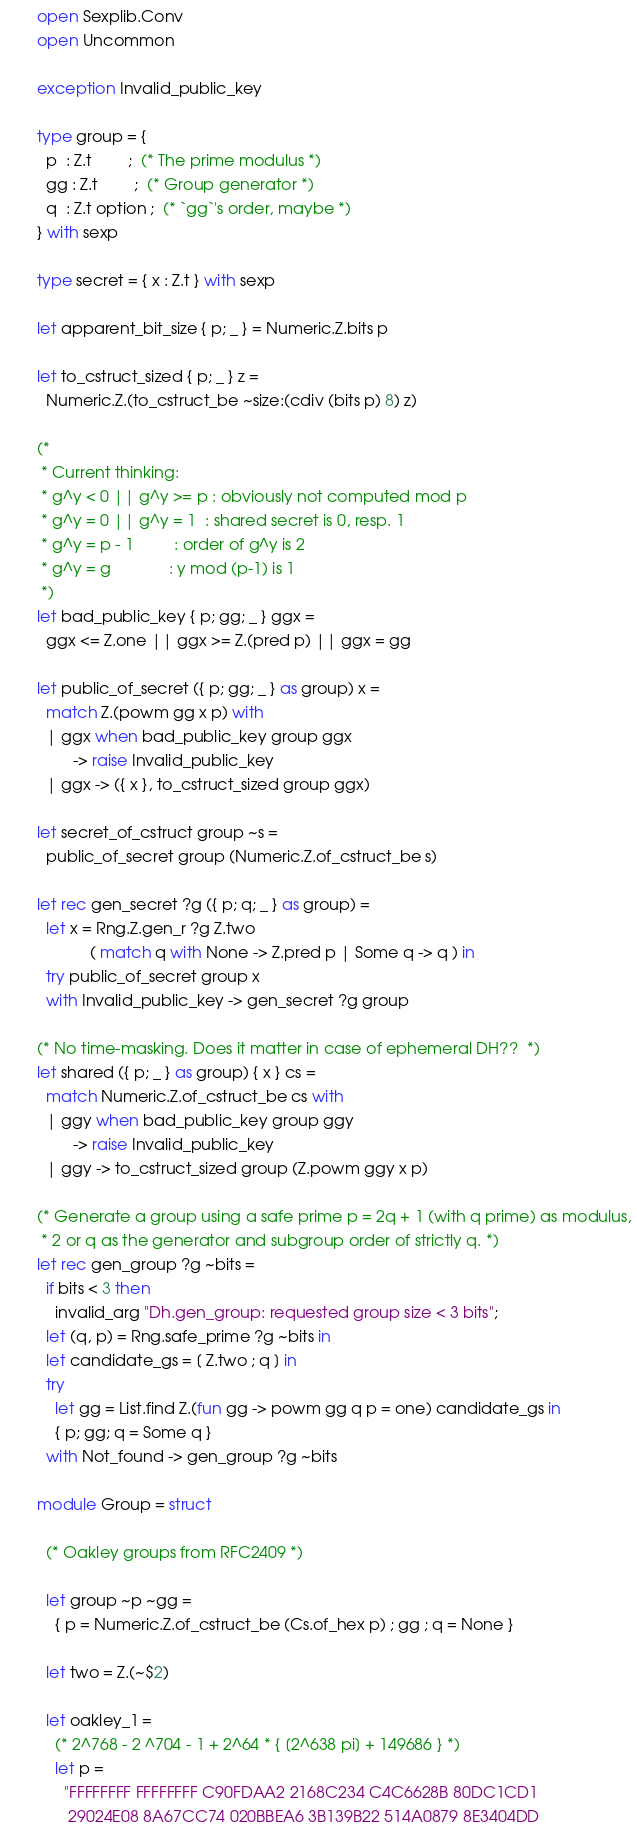<code> <loc_0><loc_0><loc_500><loc_500><_OCaml_>open Sexplib.Conv
open Uncommon

exception Invalid_public_key

type group = {
  p  : Z.t        ;  (* The prime modulus *)
  gg : Z.t        ;  (* Group generator *)
  q  : Z.t option ;  (* `gg`'s order, maybe *)
} with sexp

type secret = { x : Z.t } with sexp

let apparent_bit_size { p; _ } = Numeric.Z.bits p

let to_cstruct_sized { p; _ } z =
  Numeric.Z.(to_cstruct_be ~size:(cdiv (bits p) 8) z)

(*
 * Current thinking:
 * g^y < 0 || g^y >= p : obviously not computed mod p
 * g^y = 0 || g^y = 1  : shared secret is 0, resp. 1
 * g^y = p - 1         : order of g^y is 2
 * g^y = g             : y mod (p-1) is 1
 *)
let bad_public_key { p; gg; _ } ggx =
  ggx <= Z.one || ggx >= Z.(pred p) || ggx = gg

let public_of_secret ({ p; gg; _ } as group) x =
  match Z.(powm gg x p) with
  | ggx when bad_public_key group ggx
        -> raise Invalid_public_key
  | ggx -> ({ x }, to_cstruct_sized group ggx)

let secret_of_cstruct group ~s =
  public_of_secret group (Numeric.Z.of_cstruct_be s)

let rec gen_secret ?g ({ p; q; _ } as group) =
  let x = Rng.Z.gen_r ?g Z.two
            ( match q with None -> Z.pred p | Some q -> q ) in
  try public_of_secret group x
  with Invalid_public_key -> gen_secret ?g group

(* No time-masking. Does it matter in case of ephemeral DH??  *)
let shared ({ p; _ } as group) { x } cs =
  match Numeric.Z.of_cstruct_be cs with
  | ggy when bad_public_key group ggy
        -> raise Invalid_public_key
  | ggy -> to_cstruct_sized group (Z.powm ggy x p)

(* Generate a group using a safe prime p = 2q + 1 (with q prime) as modulus,
 * 2 or q as the generator and subgroup order of strictly q. *)
let rec gen_group ?g ~bits =
  if bits < 3 then
    invalid_arg "Dh.gen_group: requested group size < 3 bits";
  let (q, p) = Rng.safe_prime ?g ~bits in
  let candidate_gs = [ Z.two ; q ] in
  try
    let gg = List.find Z.(fun gg -> powm gg q p = one) candidate_gs in
    { p; gg; q = Some q }
  with Not_found -> gen_group ?g ~bits

module Group = struct

  (* Oakley groups from RFC2409 *)

  let group ~p ~gg =
    { p = Numeric.Z.of_cstruct_be (Cs.of_hex p) ; gg ; q = None }

  let two = Z.(~$2)

  let oakley_1 =
    (* 2^768 - 2 ^704 - 1 + 2^64 * { [2^638 pi] + 149686 } *)
    let p =
      "FFFFFFFF FFFFFFFF C90FDAA2 2168C234 C4C6628B 80DC1CD1
       29024E08 8A67CC74 020BBEA6 3B139B22 514A0879 8E3404DD</code> 